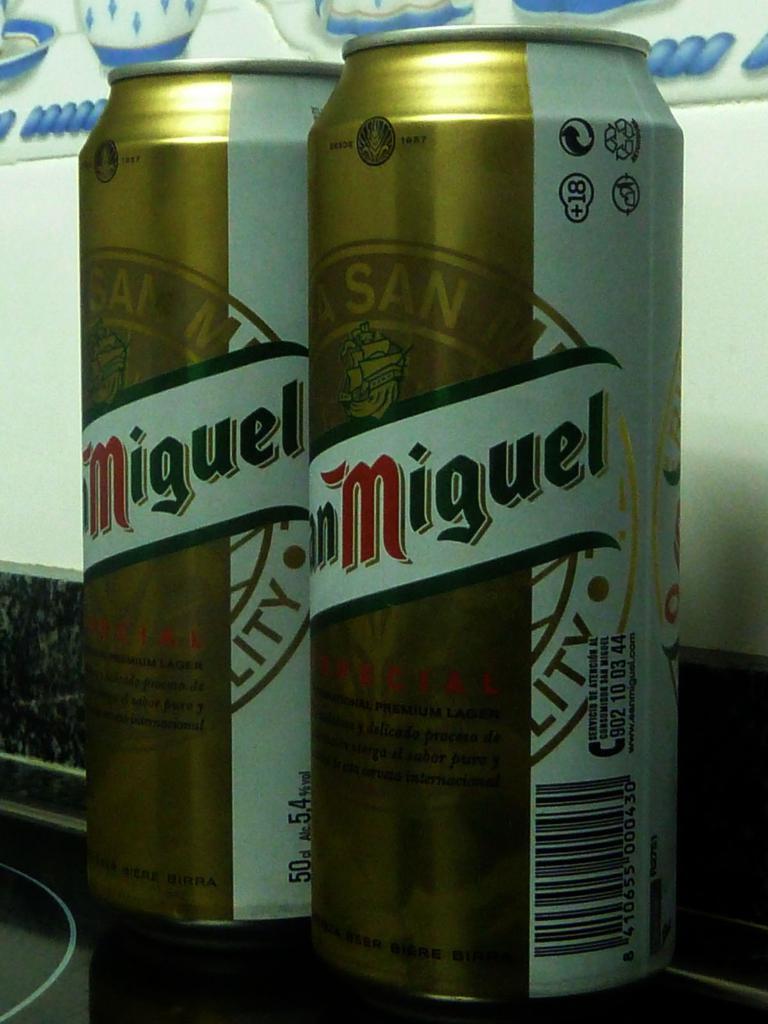What is inside of this can?
Make the answer very short. Beer. 